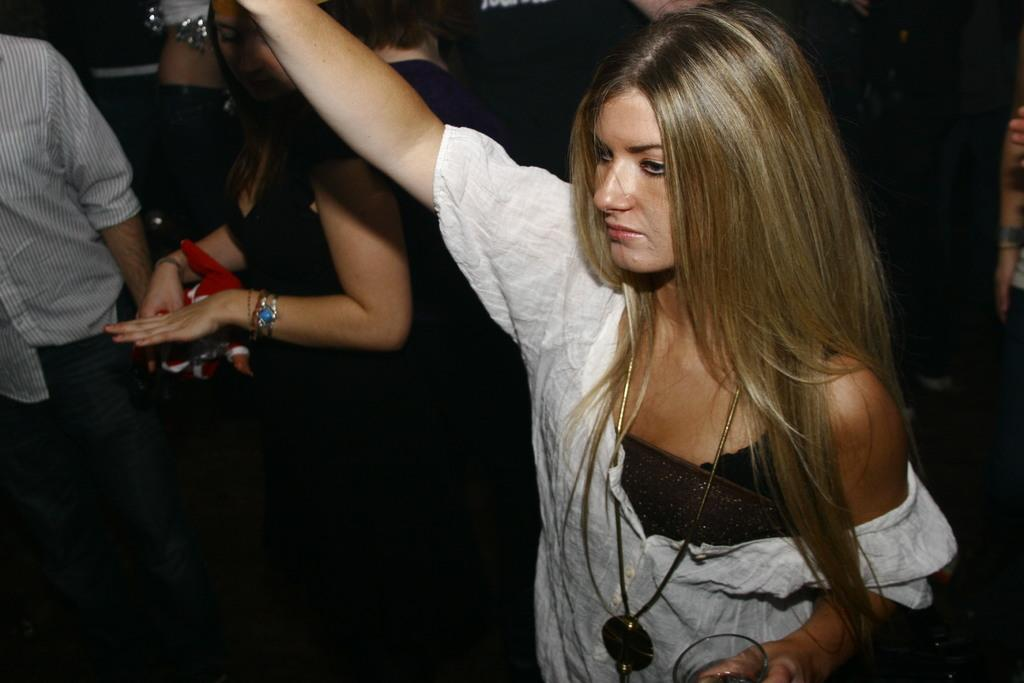What is the main subject of the image? The main subject of the image is a group of people. How are the people dressed in the image? The people are wearing different color dresses in the image. What object is being held by one of the people? One person is holding a glass in the image. What color is the background of the image? The background of the image is black. What type of government is depicted in the image? There is no depiction of a government in the image; it features a group of people wearing different color dresses and one person holding a glass. Can you see any veins in the image? There are no visible veins in the image; it focuses on the people and their clothing. 